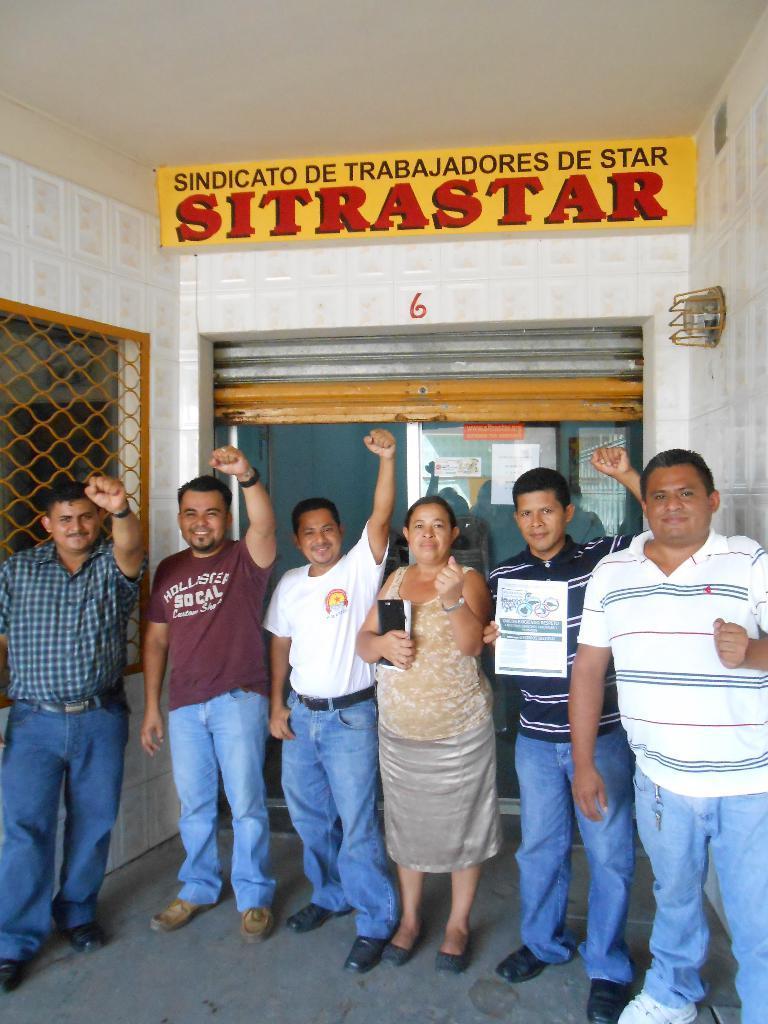Please provide a concise description of this image. In this picture I can see 5 men and a woman who are standing and I see that the man on the right is holding a thing. In the background I can see the wall and I can see the shutter in the center of this image. On the top of this image I see something is written. 